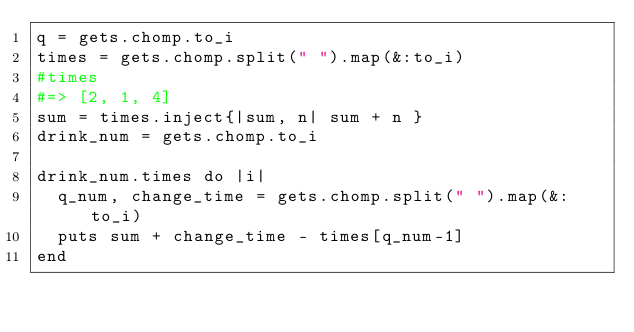<code> <loc_0><loc_0><loc_500><loc_500><_Ruby_>q = gets.chomp.to_i
times = gets.chomp.split(" ").map(&:to_i)
#times
#=> [2, 1, 4]
sum = times.inject{|sum, n| sum + n }
drink_num = gets.chomp.to_i

drink_num.times do |i|
  q_num, change_time = gets.chomp.split(" ").map(&:to_i)
  puts sum + change_time - times[q_num-1]
end


</code> 